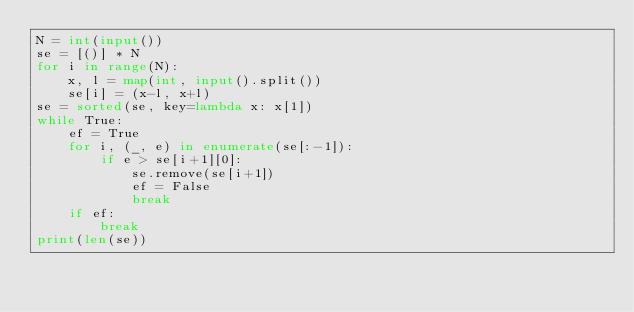Convert code to text. <code><loc_0><loc_0><loc_500><loc_500><_Python_>N = int(input())
se = [()] * N
for i in range(N):
	x, l = map(int, input().split())
	se[i] = (x-l, x+l)
se = sorted(se, key=lambda x: x[1])
while True:
	ef = True
	for i, (_, e) in enumerate(se[:-1]):
		if e > se[i+1][0]:
			se.remove(se[i+1])
			ef = False
			break
	if ef:
		break
print(len(se))</code> 